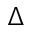<formula> <loc_0><loc_0><loc_500><loc_500>\Delta</formula> 